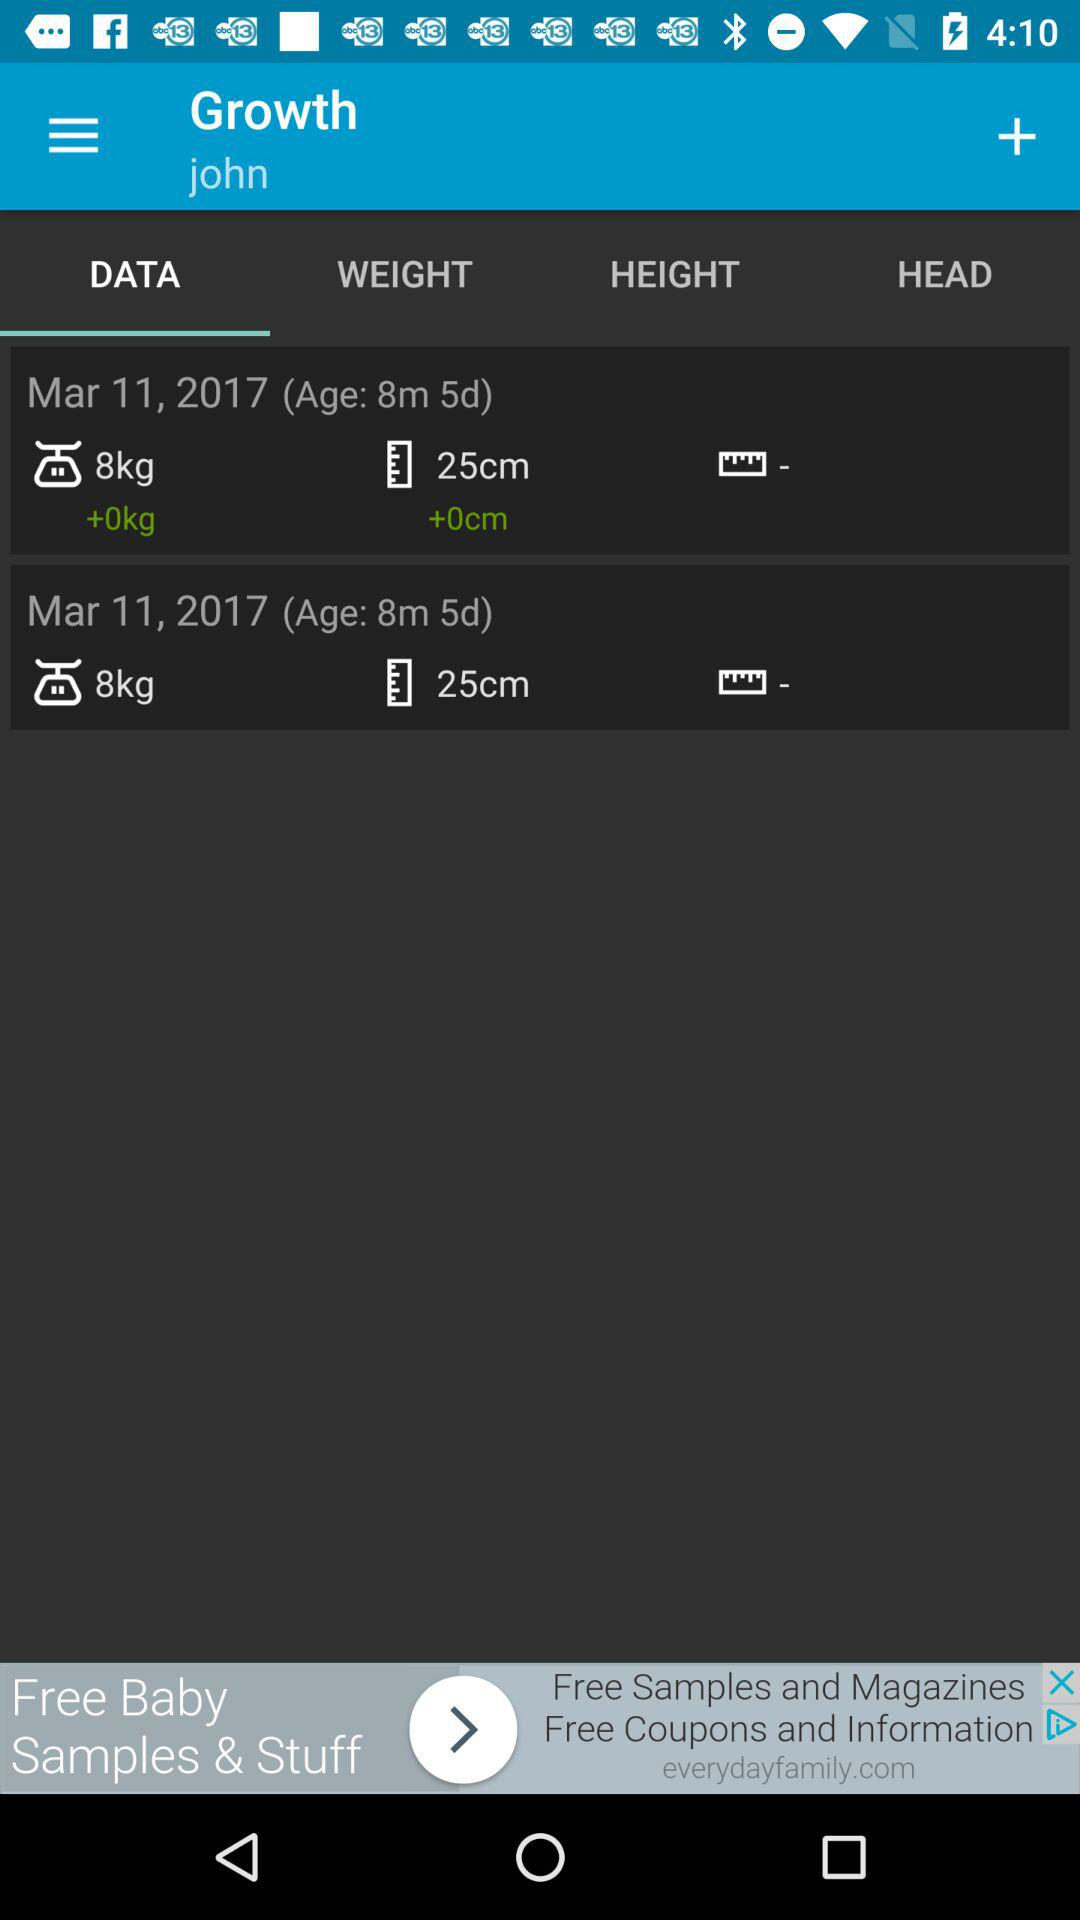What tab is selected? The selected tab is "DATA". 